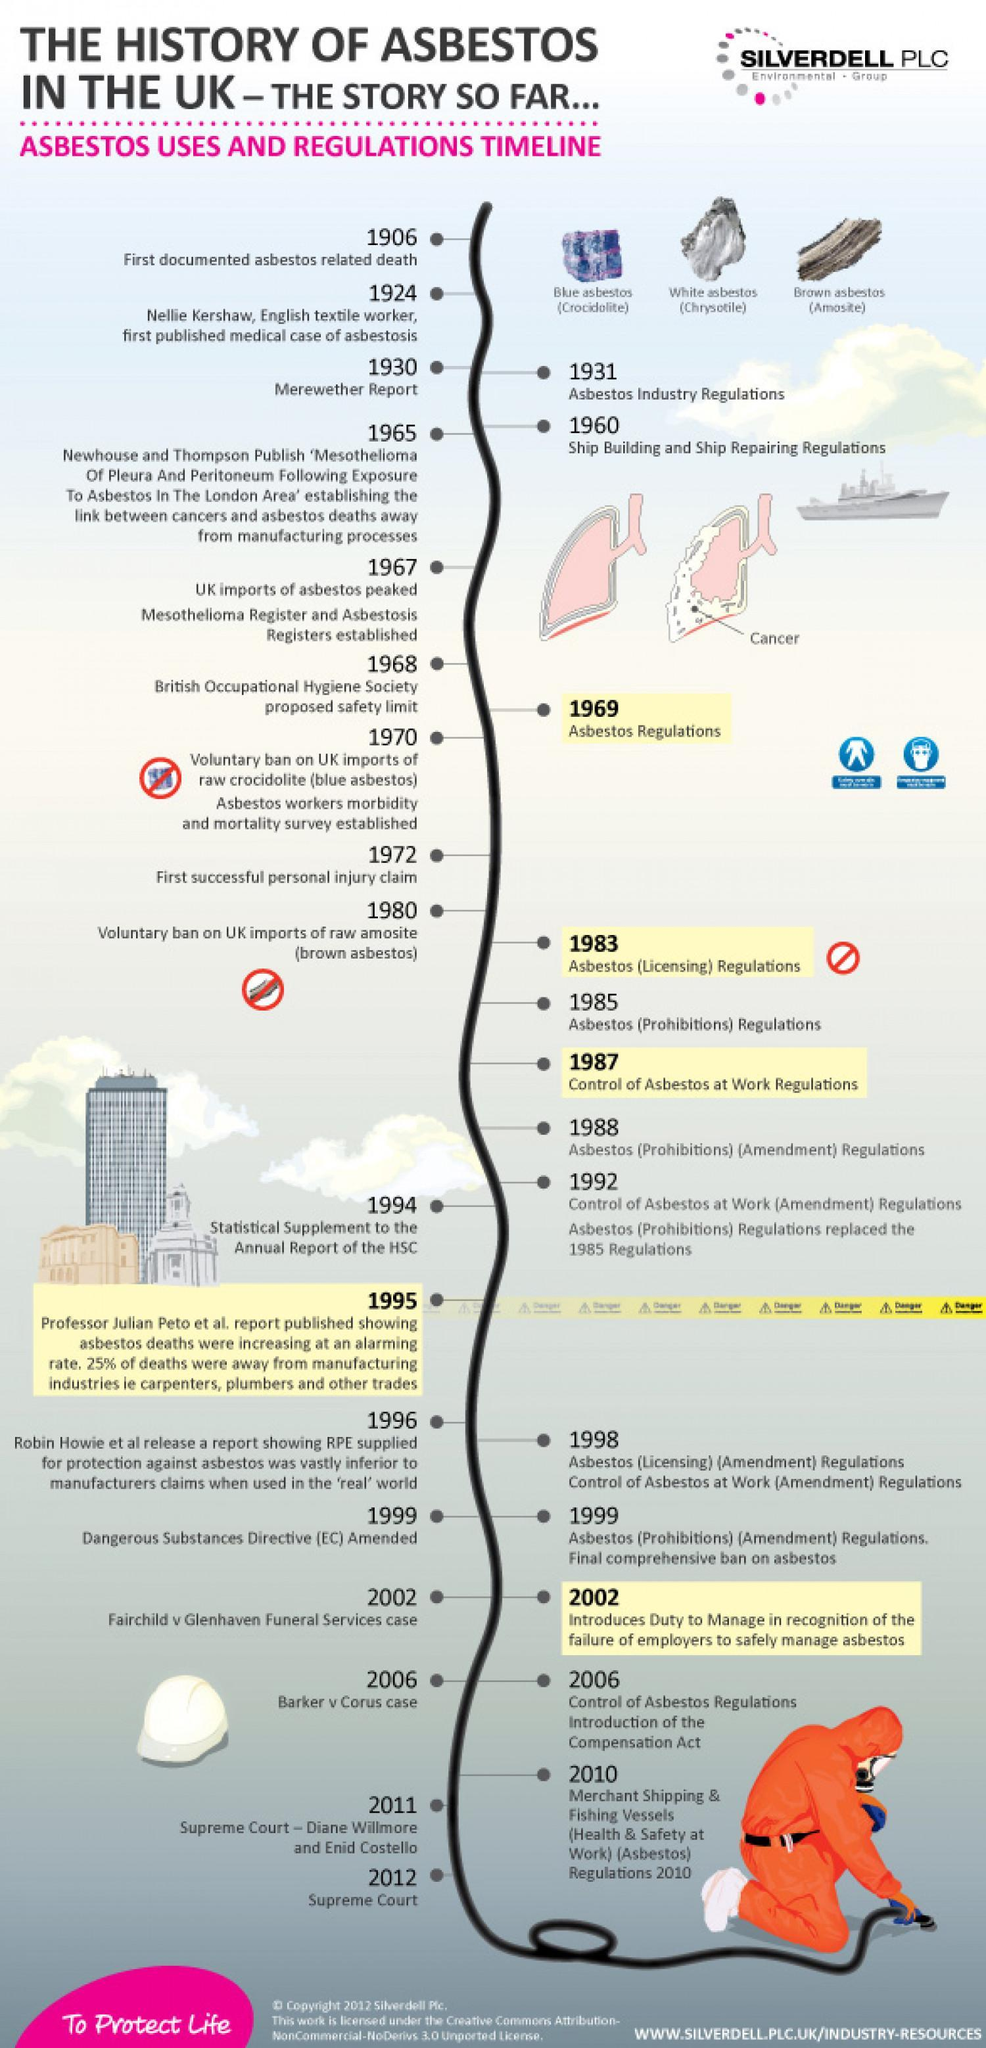When did Ship building and ship repairing regulations come into force?
Answer the question with a short phrase. 1960 When was asbestos workers morbidity and mortality survey established? 1970 What is the common name for Amosite? brown asbestos When did Newhouse and Thompson Publish a report linking cancers and asbestos deaths? 1965 What is scientific name for blue asbestos? Crocidolite Which year was the first published case of asbestosis? 1924 In which year asbestos industry regulations were published in UK? 1931 What is Chrysotile also known as? white asbestos How many types of asbestos are shown? 3 Which report was published in 1930? Merewether Report 